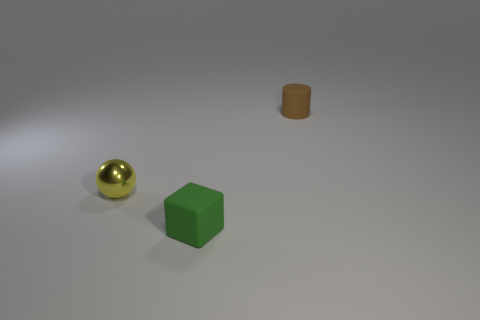There is a small matte object in front of the metal sphere; does it have the same shape as the small yellow thing?
Provide a short and direct response. No. What number of things are small yellow metallic spheres or small matte things behind the tiny yellow metallic ball?
Give a very brief answer. 2. Are there fewer gray rubber cubes than green matte objects?
Provide a short and direct response. Yes. Is the number of metallic spheres greater than the number of gray cubes?
Offer a very short reply. Yes. What number of other objects are there of the same material as the tiny yellow ball?
Ensure brevity in your answer.  0. There is a thing in front of the object that is left of the tiny green cube; what number of cylinders are in front of it?
Make the answer very short. 0. How many shiny things are small cylinders or tiny green things?
Provide a short and direct response. 0. There is a matte object in front of the thing that is to the right of the green block; how big is it?
Your response must be concise. Small. Do the tiny rubber thing behind the small yellow object and the small matte thing that is in front of the yellow shiny thing have the same color?
Make the answer very short. No. What color is the object that is in front of the brown cylinder and to the right of the yellow shiny ball?
Offer a terse response. Green. 